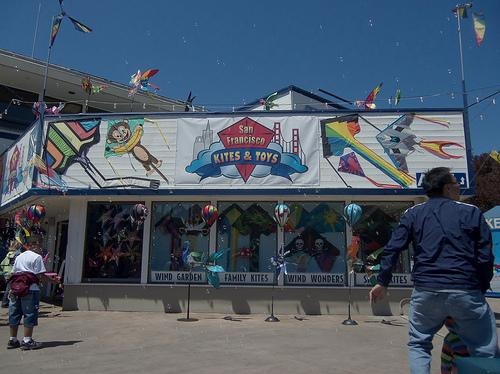Describe the store's promotional materials and the object types they pertain to. The store's signs showcase kites, including a painted jet-like kite, while there are also balloons and a monkey with a banana. Describe the overall visual atmosphere or emotional tone of the image. The image conveys a bright, playful, and cheerful atmosphere with its clear blue sky, colorful store, and happy shoppers. From the image, what is the type of store and its location? It's a kite and toy store located in San Francisco, as seen in the name and fun signs on the building's exterior. Provide a brief description of the most eye-catching element in the image. A colorful sign for San Francisco Kites & Toys on the building's façade features a playful monkey and fun kites. Paint a picture of the image by mentioning the key elements and arrangements. Under a clear blue sky, shoppers walk by a vibrant San Francisco Kites & Toys shop with vivid signs, balloons, and sidewalk shadows. What interesting finds can you spot on the store's exterior elements? There are two small rainbow flags atop a pole, white signs with black lettering in the windows, and skulls on a separate sign. What do you notice about the people presented in this image? A man wearing jeans and a blue shirt gazes upward, while a woman in a white shirt and maroon waist-tied jacket stands nearby. Identify and describe any animals present in the image. A monkey with a banana appears on the San Francisco Kites & Toys store sign, surrounded by various kite designs. Give a summary of the environment depicted in the image. The scene showcases a clear blue sky over a sidewalk in front of a kite and toy store, with colorful signs and balloons. Highlight a specific detail you see in the clothing of the people in the image. The man has a wrinkled blue jacket on, and the woman wears a maroon jacket tied around her waist over her white shirt. 